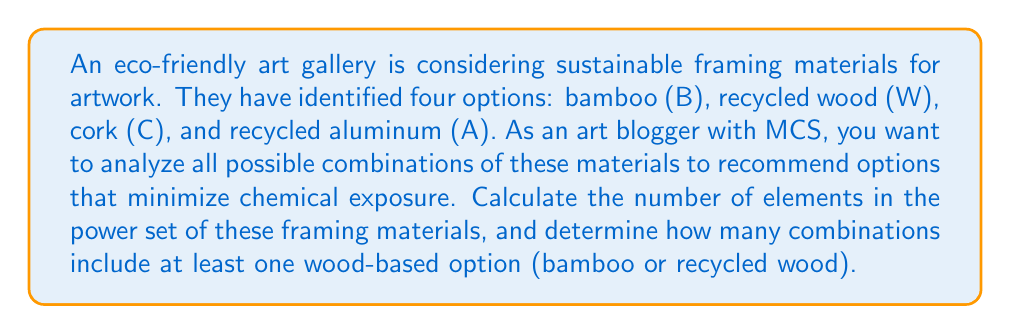Give your solution to this math problem. Let's approach this problem step by step:

1. First, we need to understand what a power set is. The power set of a set S is the set of all subsets of S, including the empty set and S itself.

2. We have 4 elements in our original set: {B, W, C, A}

3. To calculate the number of elements in the power set, we use the formula:
   $$ |P(S)| = 2^n $$
   where n is the number of elements in the original set.

4. In this case:
   $$ |P(S)| = 2^4 = 16 $$

5. Now, to determine how many combinations include at least one wood-based option (bamboo or recycled wood), we can use the complement method:
   (Total combinations) - (Combinations without wood-based options)

6. Combinations without wood-based options would only include cork and/or aluminum:
   {}, {C}, {A}, {C, A}
   This is essentially the power set of {C, A}, which has $2^2 = 4$ elements.

7. Therefore, the number of combinations with at least one wood-based option is:
   $$ 16 - 4 = 12 $$

This approach ensures considering all possible combinations while focusing on wood-based options that may be preferable for those with MCS due to their natural properties.
Answer: The power set of the sustainable framing materials contains 16 elements. Of these, 12 combinations include at least one wood-based option (bamboo or recycled wood). 